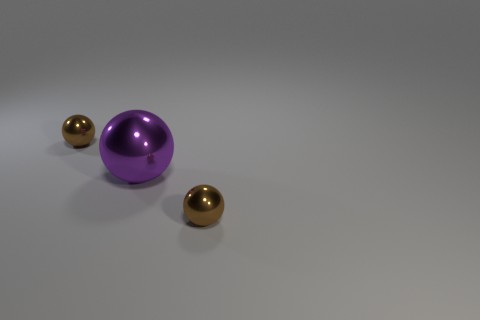Are there any other things that have the same shape as the large object?
Make the answer very short. Yes. Are the big purple thing and the sphere behind the large thing made of the same material?
Provide a succinct answer. Yes. Is there any other thing that is the same size as the purple metal object?
Make the answer very short. No. How many objects are purple objects or small metallic things that are in front of the purple object?
Your answer should be very brief. 2. There is a metal object in front of the large shiny ball; is it the same size as the brown shiny ball that is behind the large purple object?
Offer a terse response. Yes. Does the purple sphere have the same size as the thing that is behind the large ball?
Provide a short and direct response. No. What is the size of the brown metal sphere on the right side of the small brown metal ball behind the large metal object?
Offer a terse response. Small. Are there an equal number of tiny brown spheres on the right side of the large purple metal sphere and purple metal things?
Your answer should be very brief. Yes. There is a brown thing that is on the right side of the purple shiny thing; are there any tiny brown objects that are in front of it?
Offer a terse response. No. There is a purple shiny sphere that is to the right of the small brown ball to the left of the brown sphere that is on the right side of the purple metallic ball; what size is it?
Your response must be concise. Large. 